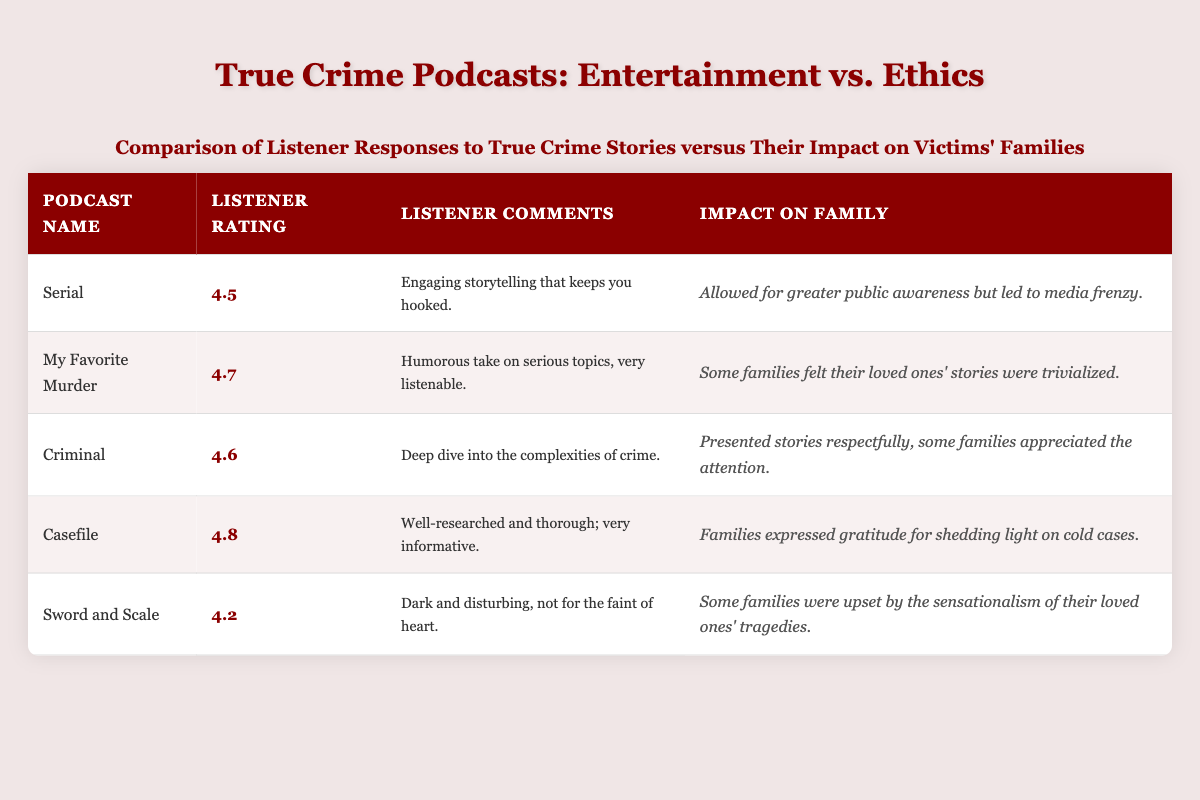What is the highest listener rating among the podcasts listed? The listener ratings are 4.5 for Serial, 4.7 for My Favorite Murder, 4.6 for Criminal, 4.8 for Casefile, and 4.2 for Sword and Scale. The highest rating is 4.8 from Casefile.
Answer: 4.8 Which podcast has listener comments indicating a humorous take on serious topics? Looking at the listener comments in the table, My Favorite Murder has the comment stating it has a "humorous take on serious topics."
Answer: My Favorite Murder What is the average listener rating of all the podcasts listed? First, add the listener ratings: 4.5 + 4.7 + 4.6 + 4.8 + 4.2 = 24.8. Then, divide by the number of podcasts (5): 24.8 / 5 = 4.96.
Answer: 4.96 Do any podcasts mention that families appreciated the attention given to their stories? Criminal and Casefile both have impacts on families indicating appreciation: Criminal states, "some families appreciated the attention," and Casefile mentions, "families expressed gratitude for shedding light on cold cases."
Answer: Yes Which podcast had the most impactful response on families regarding media attention? Analyzing the impact on families, Serial's impact mentions greater public awareness leading to a media frenzy, while Casefile's indicated gratitude from families. Since media frenzy often has negative connotations related to excess attention, Serial seems to have the strongest negative impact.
Answer: Serial How many podcasts received ratings of 4.5 or higher? The podcasts with ratings of 4.5 or higher are Serial (4.5), My Favorite Murder (4.7), Criminal (4.6), Casefile (4.8), and Sword and Scale (4.2). Four podcasts have ratings at or above 4.5, which makes it a count of 4.
Answer: 4 Are there any podcasts that families felt their loved ones’ stories were trivialized? The table indicates that My Favorite Murder mentions that "some families felt their loved ones' stories were trivialized."
Answer: Yes Which podcast had listener comments that describe it as "dark and disturbing"? The comments for Sword and Scale specifically describe it as "dark and disturbing, not for the faint of heart."
Answer: Sword and Scale 